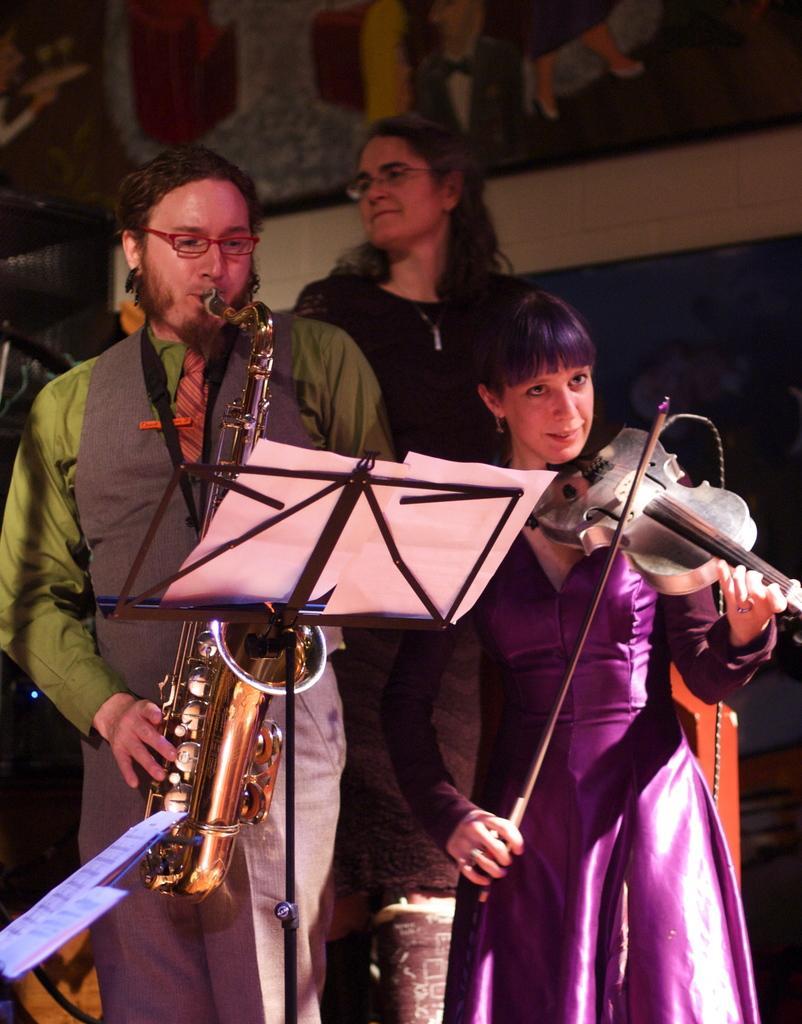Please provide a concise description of this image. In this image a man wearing a green shirt is playing the saxophone. beside him a woman wearing a purple dress is playing violin. In front of them there is a stand. On the stand there is a paper with notes. Behind them there is a lady standing. In the background there is a wall on it there is a painting. 